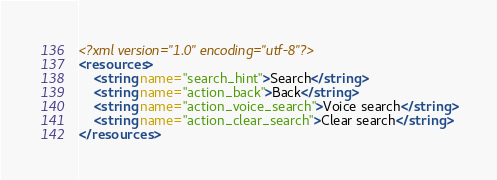<code> <loc_0><loc_0><loc_500><loc_500><_XML_><?xml version="1.0" encoding="utf-8"?>
<resources>
    <string name="search_hint">Search</string>
    <string name="action_back">Back</string>
    <string name="action_voice_search">Voice search</string>
    <string name="action_clear_search">Clear search</string>
</resources>
</code> 